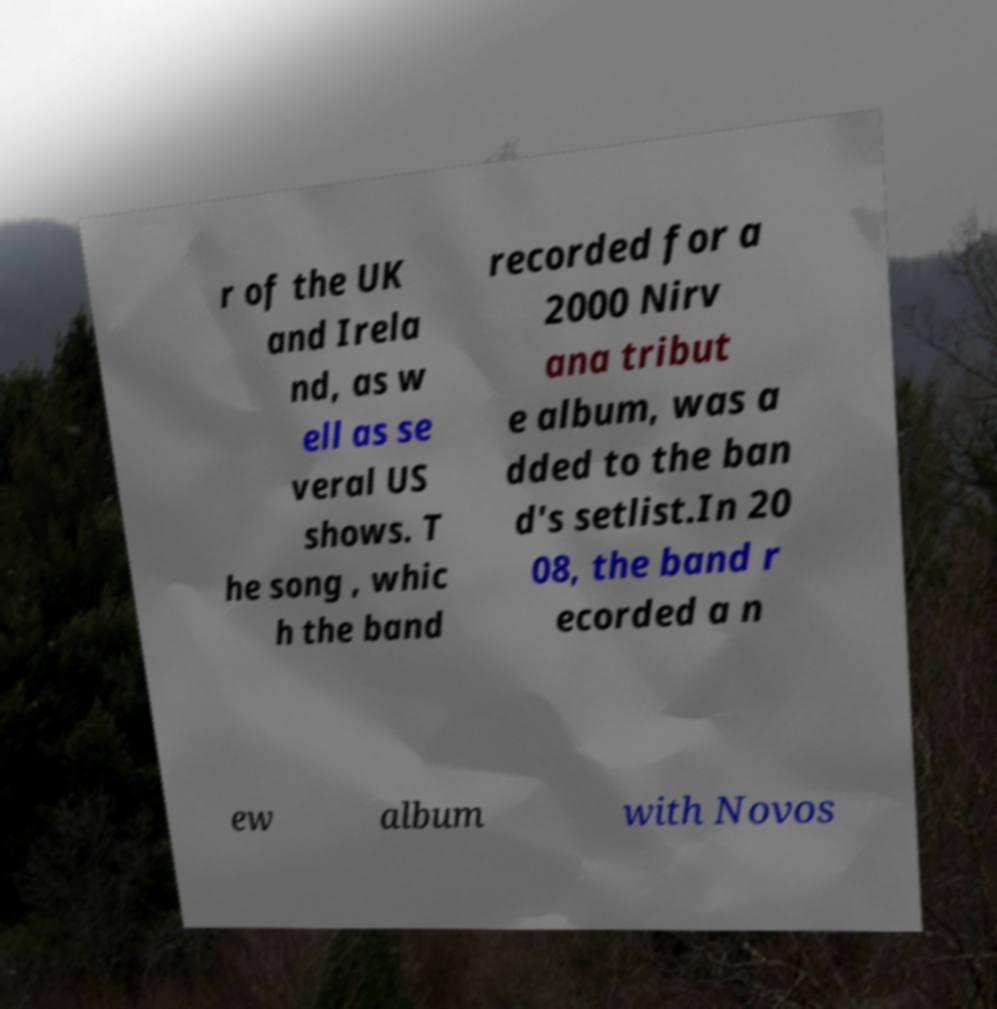Can you accurately transcribe the text from the provided image for me? r of the UK and Irela nd, as w ell as se veral US shows. T he song , whic h the band recorded for a 2000 Nirv ana tribut e album, was a dded to the ban d's setlist.In 20 08, the band r ecorded a n ew album with Novos 